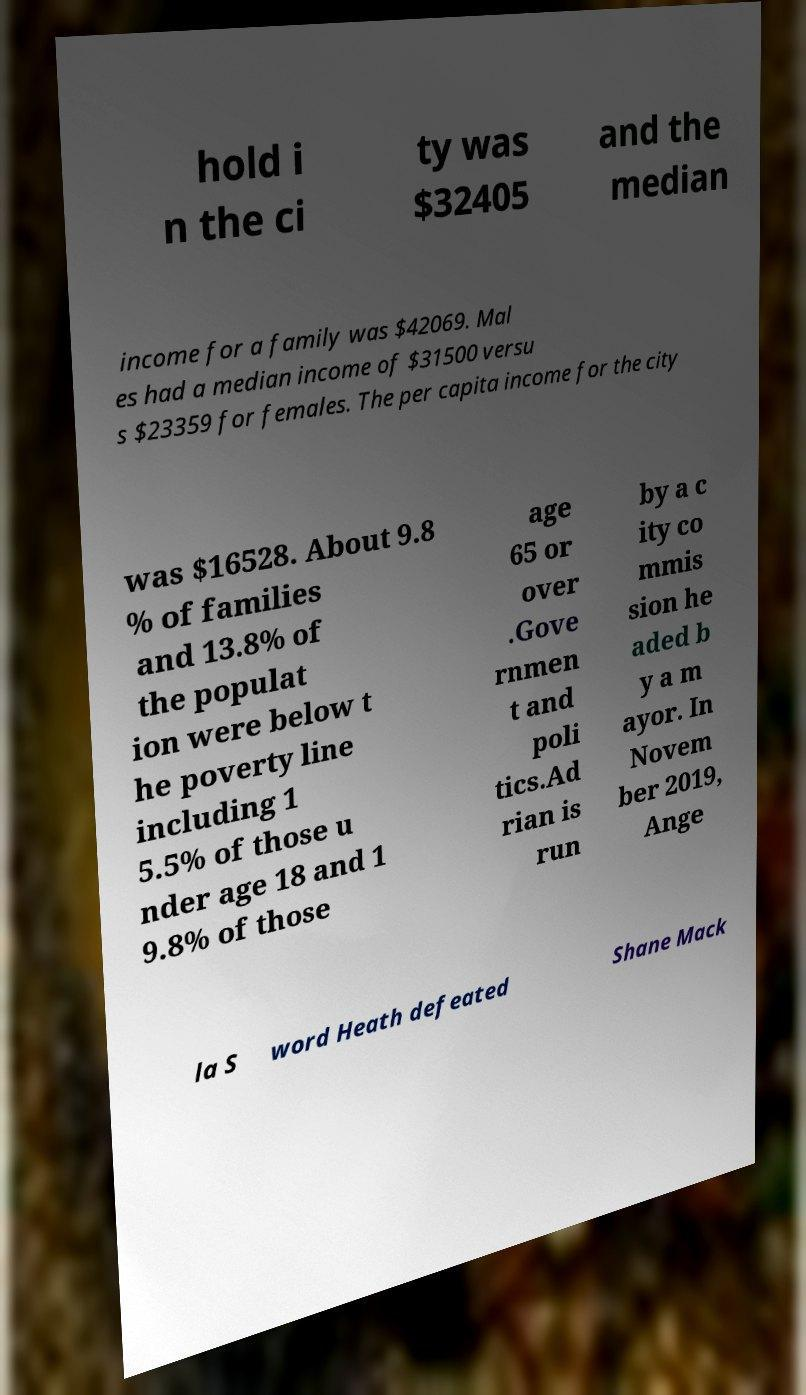Could you assist in decoding the text presented in this image and type it out clearly? hold i n the ci ty was $32405 and the median income for a family was $42069. Mal es had a median income of $31500 versu s $23359 for females. The per capita income for the city was $16528. About 9.8 % of families and 13.8% of the populat ion were below t he poverty line including 1 5.5% of those u nder age 18 and 1 9.8% of those age 65 or over .Gove rnmen t and poli tics.Ad rian is run by a c ity co mmis sion he aded b y a m ayor. In Novem ber 2019, Ange la S word Heath defeated Shane Mack 